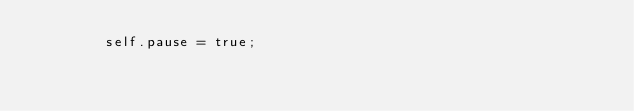<code> <loc_0><loc_0><loc_500><loc_500><_Rust_>        self.pause = true;</code> 